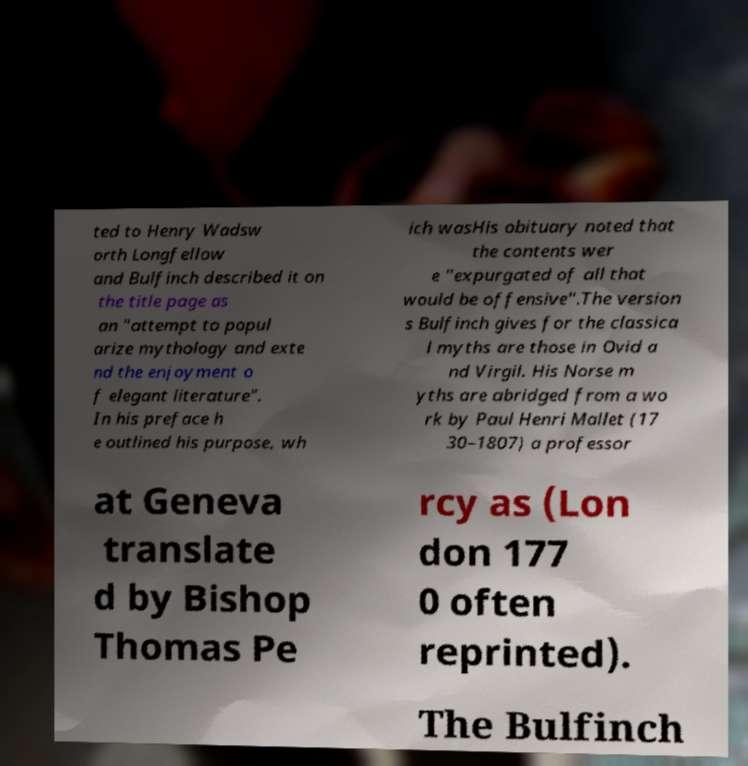I need the written content from this picture converted into text. Can you do that? ted to Henry Wadsw orth Longfellow and Bulfinch described it on the title page as an "attempt to popul arize mythology and exte nd the enjoyment o f elegant literature". In his preface h e outlined his purpose, wh ich wasHis obituary noted that the contents wer e "expurgated of all that would be offensive".The version s Bulfinch gives for the classica l myths are those in Ovid a nd Virgil. His Norse m yths are abridged from a wo rk by Paul Henri Mallet (17 30–1807) a professor at Geneva translate d by Bishop Thomas Pe rcy as (Lon don 177 0 often reprinted). The Bulfinch 